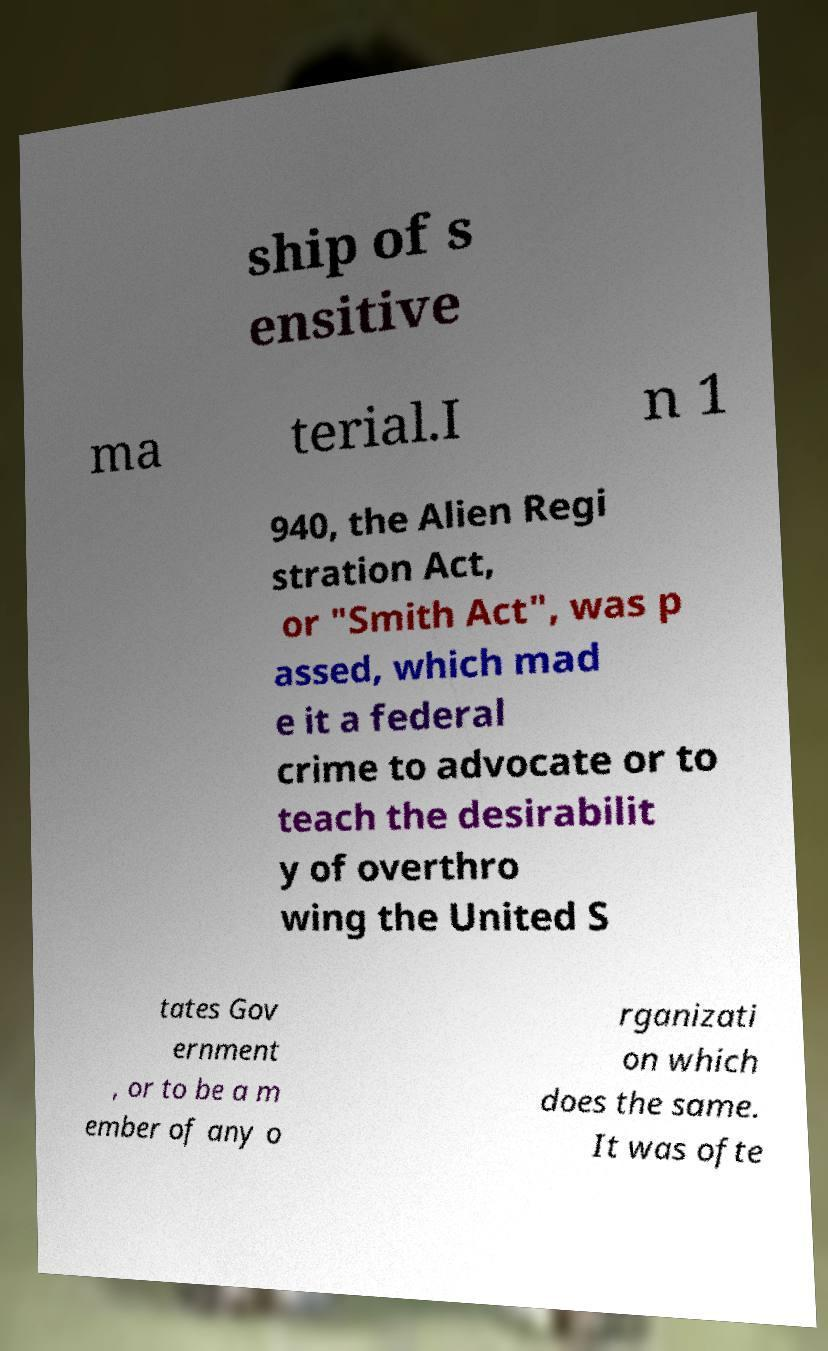I need the written content from this picture converted into text. Can you do that? ship of s ensitive ma terial.I n 1 940, the Alien Regi stration Act, or "Smith Act", was p assed, which mad e it a federal crime to advocate or to teach the desirabilit y of overthro wing the United S tates Gov ernment , or to be a m ember of any o rganizati on which does the same. It was ofte 